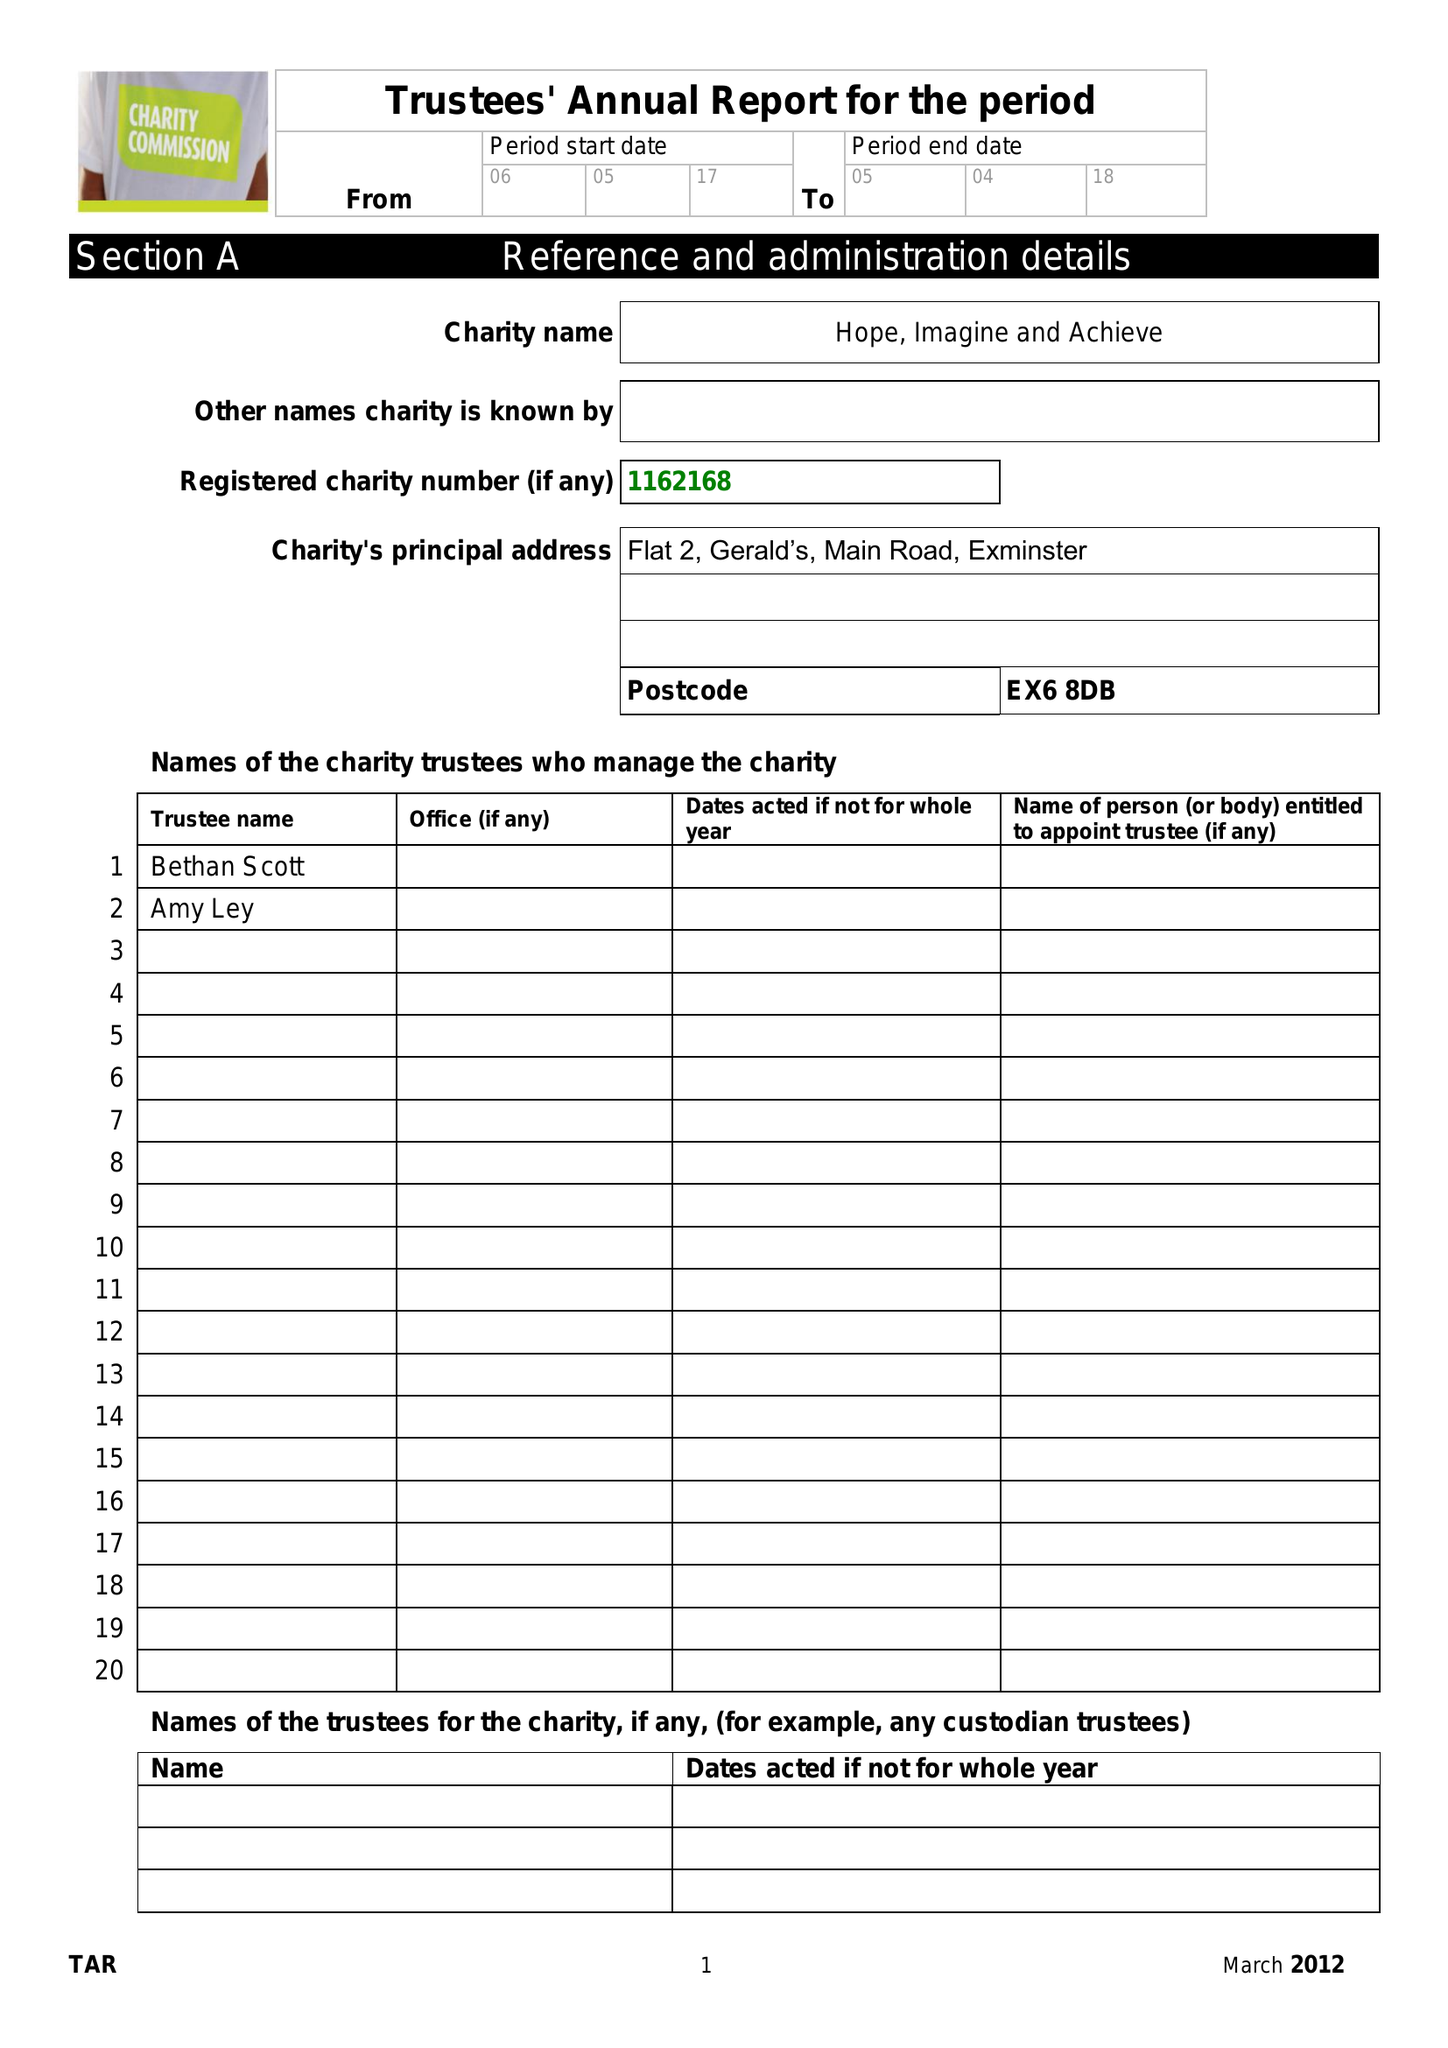What is the value for the income_annually_in_british_pounds?
Answer the question using a single word or phrase. 5000.00 